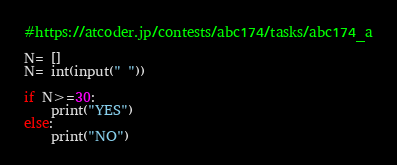Convert code to text. <code><loc_0><loc_0><loc_500><loc_500><_Python_>#https://atcoder.jp/contests/abc174/tasks/abc174_a

N= []
N= int(input(" "))

if N>=30:
    print("YES")
else:
    print("NO")</code> 